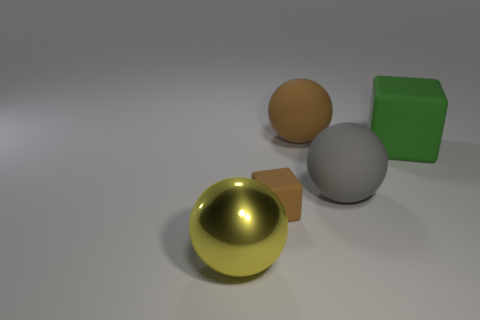Add 4 large yellow spheres. How many objects exist? 9 Subtract all big gray spheres. How many spheres are left? 2 Subtract 2 blocks. How many blocks are left? 0 Subtract all brown cubes. How many cubes are left? 1 Subtract all balls. How many objects are left? 2 Subtract all brown spheres. Subtract all brown cylinders. How many spheres are left? 2 Subtract all gray objects. Subtract all small cubes. How many objects are left? 3 Add 4 small rubber objects. How many small rubber objects are left? 5 Add 1 metal cylinders. How many metal cylinders exist? 1 Subtract 0 cyan balls. How many objects are left? 5 